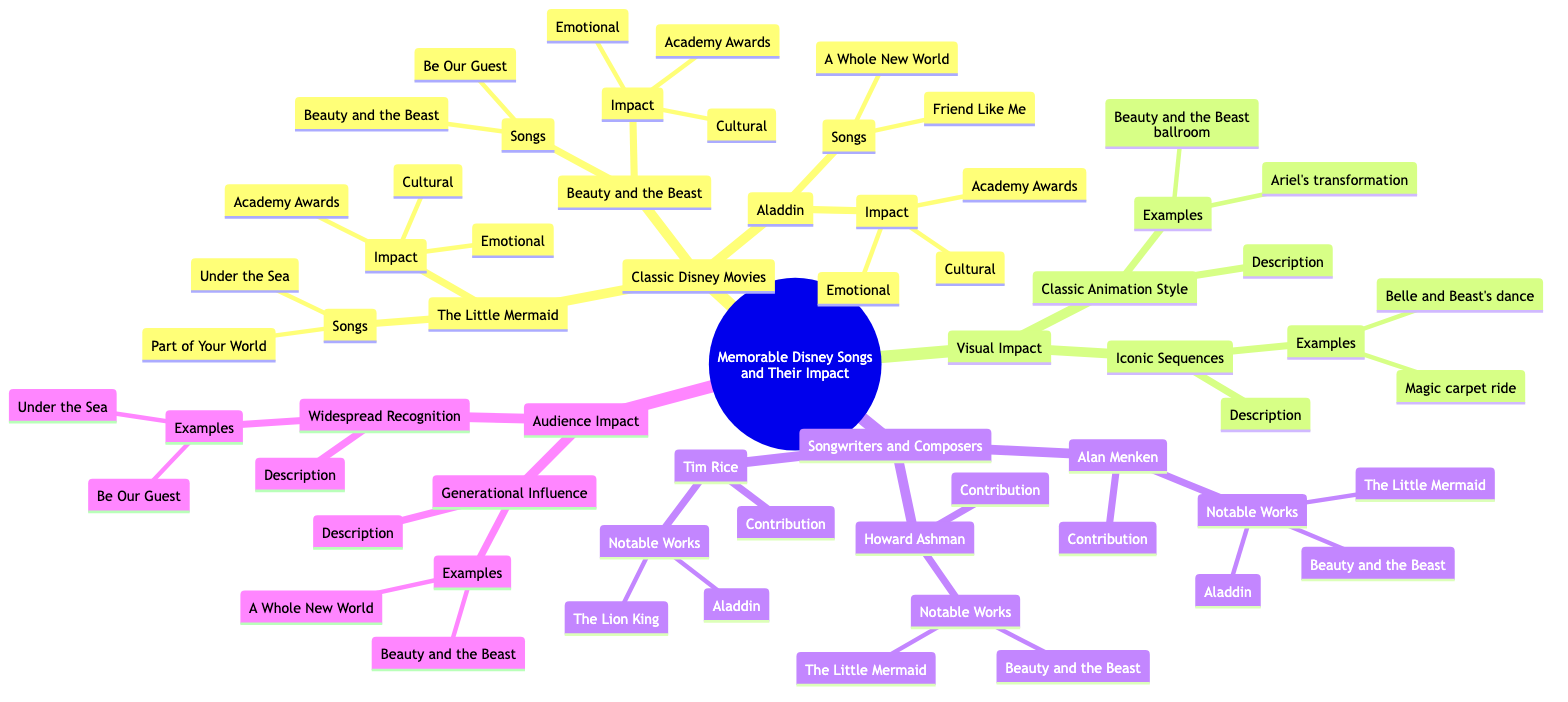What is the song from The Little Mermaid that won an Academy Award? The diagram indicates that "Under the Sea" is the song associated with "The Little Mermaid" that received an Academy Award under the category Best Original Song.
Answer: Under the Sea How many songs are listed for Aladdin? The section for "Aladdin" shows two songs, specifically "A Whole New World" and "Friend Like Me." The count of these songs totals to two.
Answer: 2 What element revitalized animated musicals according to The Little Mermaid's impact? The "Cultural" impact of "The Little Mermaid" notes that it revitalized animated musicals, connecting the movie's significance directly to cultural shifts in animation.
Answer: Revitalized animated musicals Which song from Beauty and the Beast is recognized for its emotional depth? The contribution of Howard Ashman, the lyricist for "Beauty and the Beast," mentions that his works infused songs with emotional depth, making both "Beauty and the Beast" and "Be Our Guest" strong candidates. However, since "Beauty and the Beast" is noted as winning an Academy Award, it likely holds greater emotional resonance.
Answer: Beauty and the Beast What two notable works are attributed to Tim Rice? The diagram lists Tim Rice's contributions and states that his notable works include "Aladdin" and "The Lion King." Therefore, referencing both these works provides a comprehensive answer.
Answer: Aladdin, The Lion King What describes the classic animation style? Within the Visual Impact section, the description of the "Classic Animation Style" notes that it contributes emotional depth, which summarizes the significant characteristic of this animation approach.
Answer: Hand-drawn animation that adds emotional depth Which song is cited as an example of widespread recognition? The "Widespread Recognition" section illustrates that "Under the Sea" is explicitly mentioned as one of the songs that is instantly recognizable and universally loved, making it a direct answer to the question.
Answer: Under the Sea How many examples are given for Iconic Sequences? The "Iconic Sequences" element includes two specific examples in the diagram—"Aladdin and Jasmine's magic carpet ride" and "Belle and the Beast's first dance"—thus the count of these examples is two.
Answer: 2 Which movie's song inspired a generation's love for the sea and adventure? The emotional impact of "The Little Mermaid" reveals that the song associated with it inspired a generation's love for the sea and adventure, making "The Little Mermaid" the answer.
Answer: The Little Mermaid 